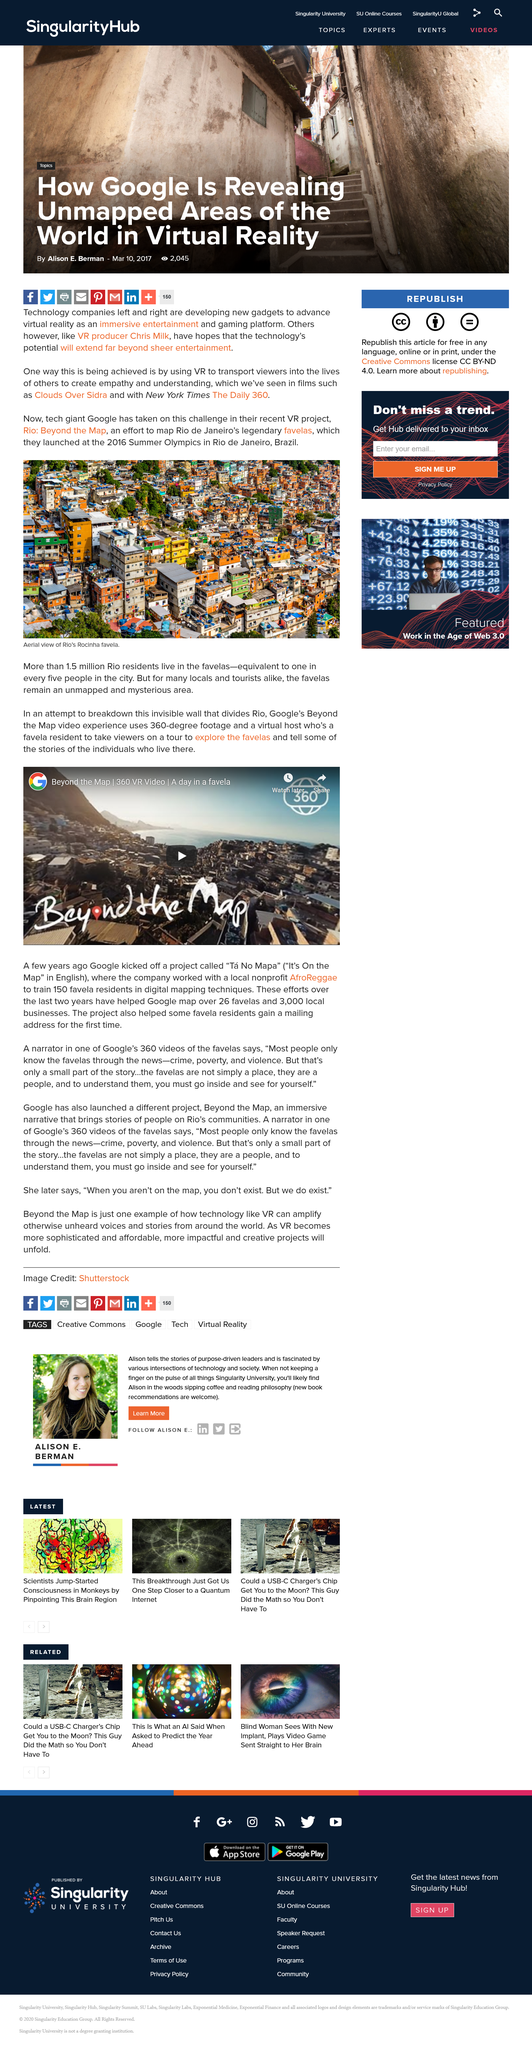Mention a couple of crucial points in this snapshot. The article was made by Alison E. Berman. The article was created on March 10, 2017. Approximately 2045 people have viewed this article. 